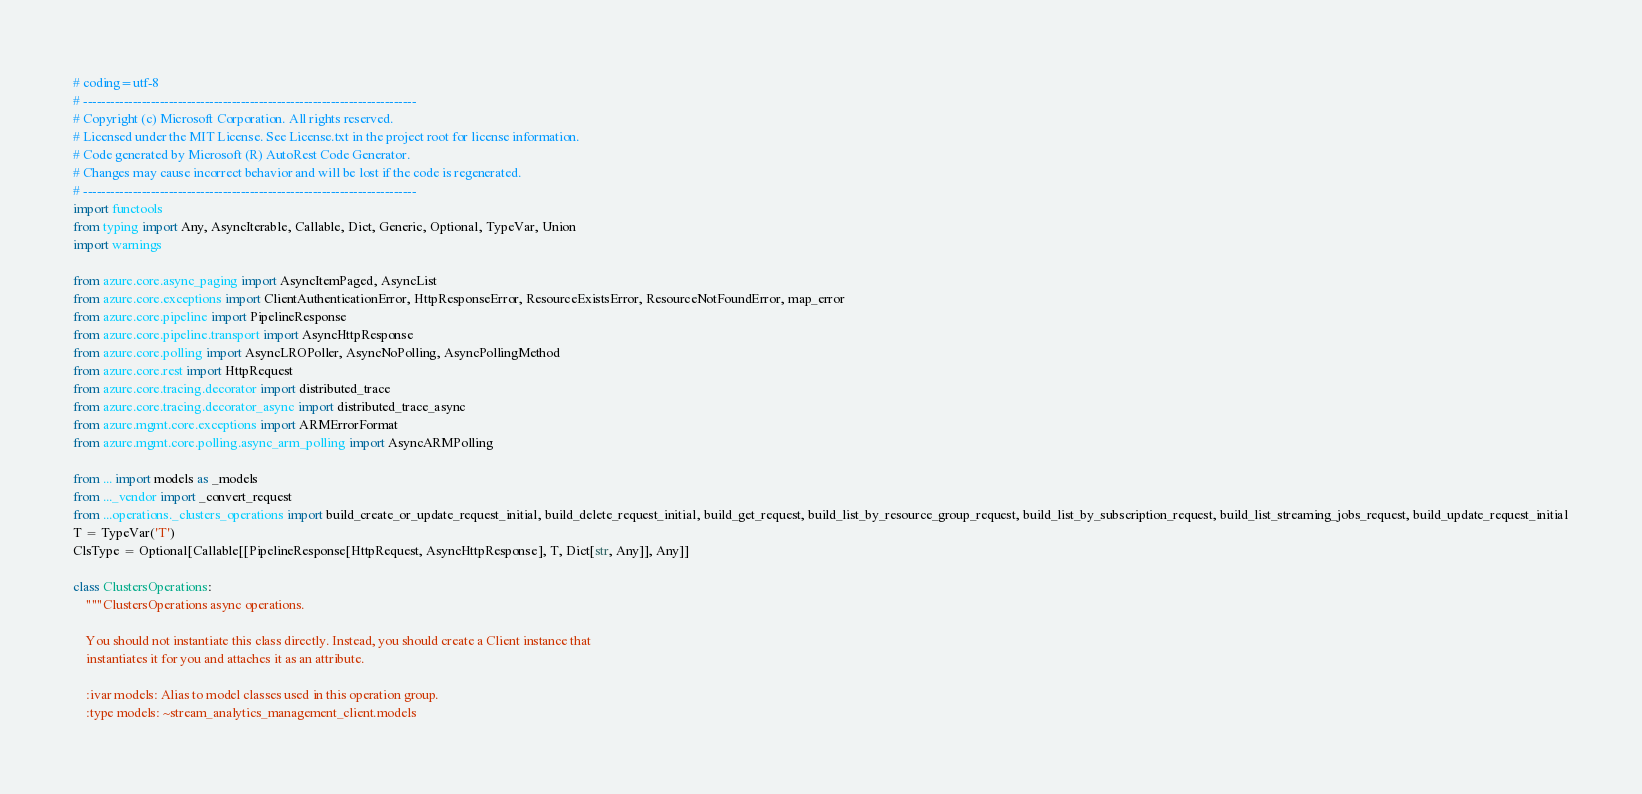<code> <loc_0><loc_0><loc_500><loc_500><_Python_># coding=utf-8
# --------------------------------------------------------------------------
# Copyright (c) Microsoft Corporation. All rights reserved.
# Licensed under the MIT License. See License.txt in the project root for license information.
# Code generated by Microsoft (R) AutoRest Code Generator.
# Changes may cause incorrect behavior and will be lost if the code is regenerated.
# --------------------------------------------------------------------------
import functools
from typing import Any, AsyncIterable, Callable, Dict, Generic, Optional, TypeVar, Union
import warnings

from azure.core.async_paging import AsyncItemPaged, AsyncList
from azure.core.exceptions import ClientAuthenticationError, HttpResponseError, ResourceExistsError, ResourceNotFoundError, map_error
from azure.core.pipeline import PipelineResponse
from azure.core.pipeline.transport import AsyncHttpResponse
from azure.core.polling import AsyncLROPoller, AsyncNoPolling, AsyncPollingMethod
from azure.core.rest import HttpRequest
from azure.core.tracing.decorator import distributed_trace
from azure.core.tracing.decorator_async import distributed_trace_async
from azure.mgmt.core.exceptions import ARMErrorFormat
from azure.mgmt.core.polling.async_arm_polling import AsyncARMPolling

from ... import models as _models
from ..._vendor import _convert_request
from ...operations._clusters_operations import build_create_or_update_request_initial, build_delete_request_initial, build_get_request, build_list_by_resource_group_request, build_list_by_subscription_request, build_list_streaming_jobs_request, build_update_request_initial
T = TypeVar('T')
ClsType = Optional[Callable[[PipelineResponse[HttpRequest, AsyncHttpResponse], T, Dict[str, Any]], Any]]

class ClustersOperations:
    """ClustersOperations async operations.

    You should not instantiate this class directly. Instead, you should create a Client instance that
    instantiates it for you and attaches it as an attribute.

    :ivar models: Alias to model classes used in this operation group.
    :type models: ~stream_analytics_management_client.models</code> 